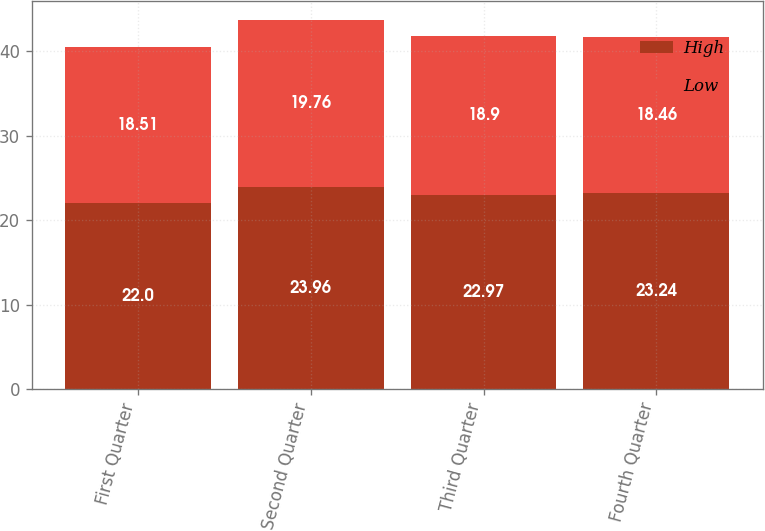Convert chart. <chart><loc_0><loc_0><loc_500><loc_500><stacked_bar_chart><ecel><fcel>First Quarter<fcel>Second Quarter<fcel>Third Quarter<fcel>Fourth Quarter<nl><fcel>High<fcel>22<fcel>23.96<fcel>22.97<fcel>23.24<nl><fcel>Low<fcel>18.51<fcel>19.76<fcel>18.9<fcel>18.46<nl></chart> 